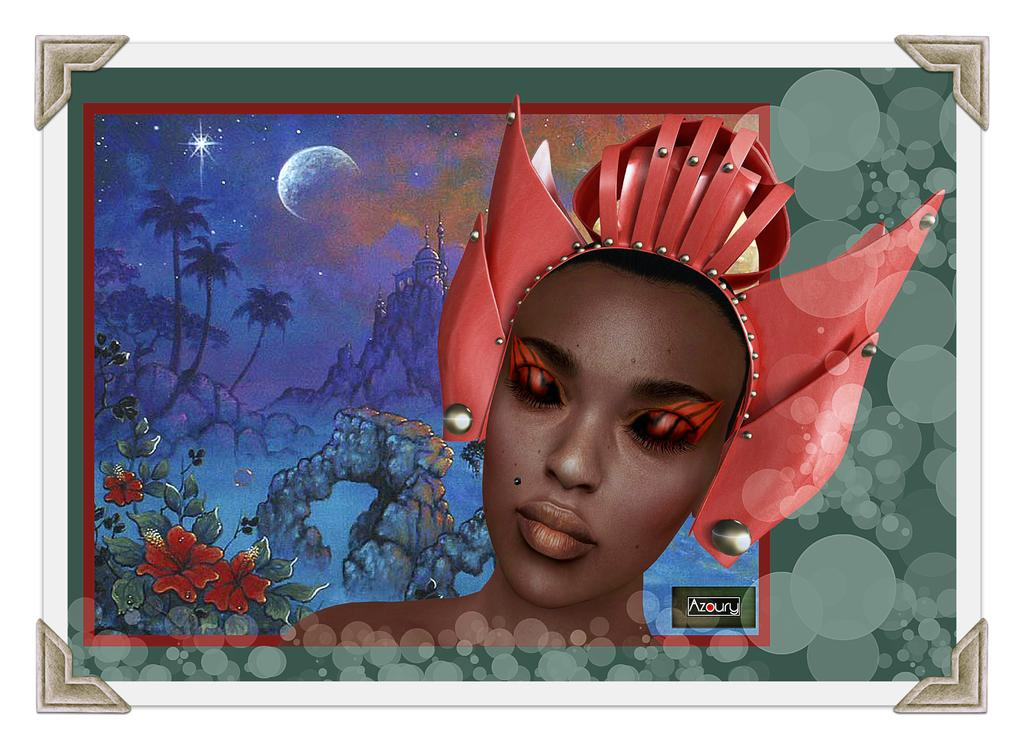What type of artwork is described in the image? The image is a painting. What subject is depicted in the painting? There is a woman's face depicted in the painting. What can be seen in the background of the painting? There is a moon, trees, and a hill in the background of the painting. How many cows are grazing on the hill in the painting? There are no cows present in the painting; it features a woman's face, a moon, trees, and a hill. What type of badge is the woman wearing in the painting? There is no badge depicted on the woman in the painting. 